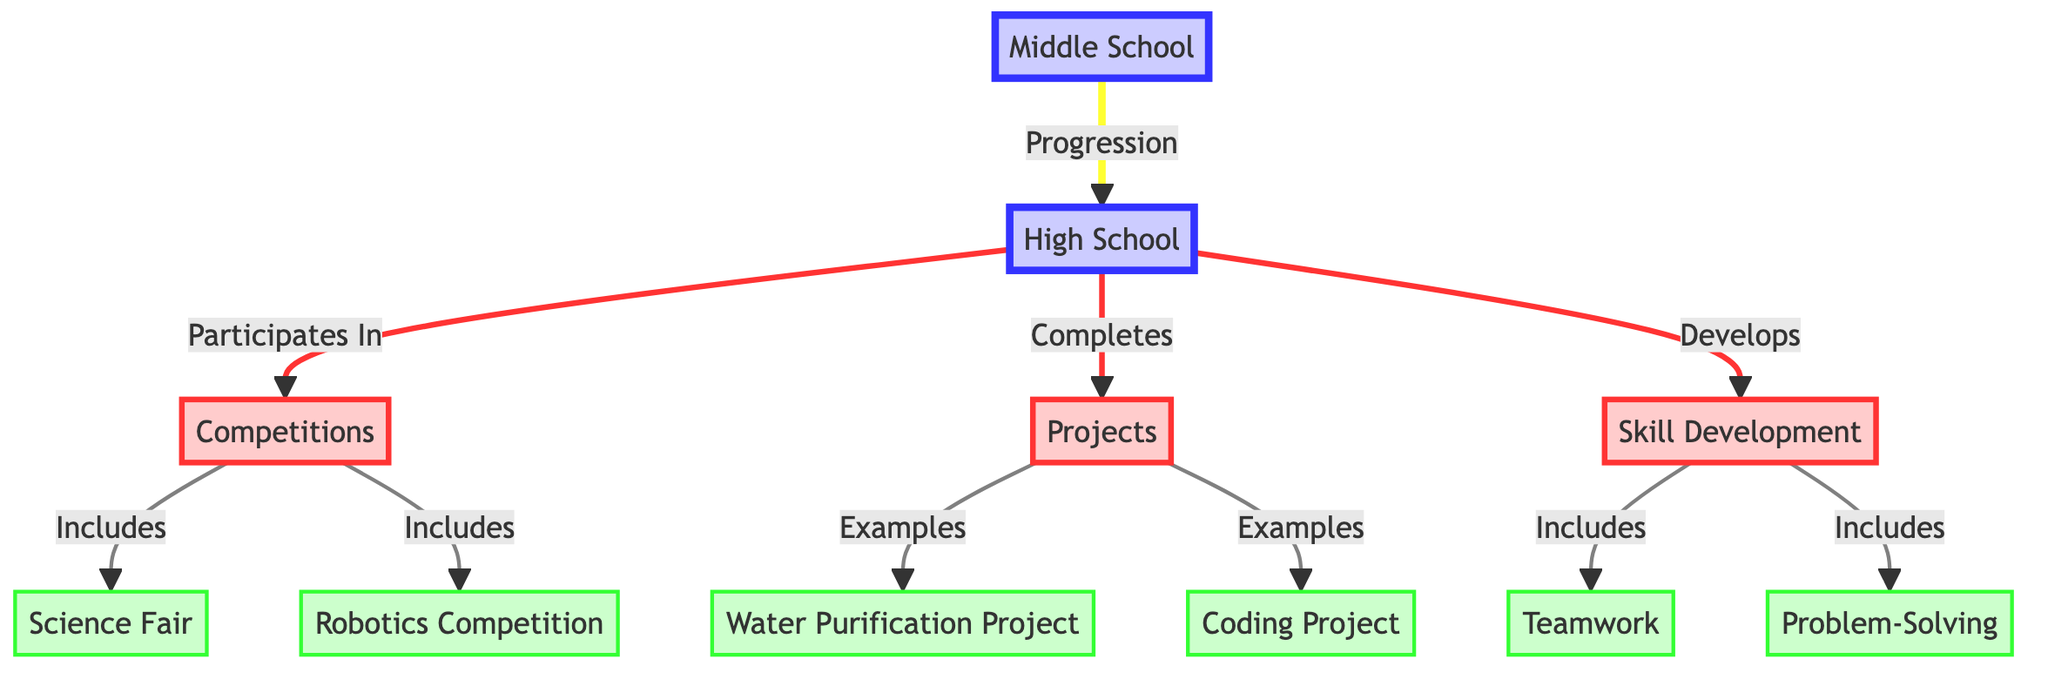What age groups are represented in the diagram? The diagram compares two age groups: Middle School and High School, as indicated by the two main nodes labeled accordingly.
Answer: Middle School, High School How many categories of achievements are shown in the diagram? The diagram has three distinct categories: Competitions, Projects, and Skill Development. This can be verified by counting the nodes connected to the age group nodes that signify these categories.
Answer: Three Which competition is included under the Competitions category? In the diagram, one of the competitions listed is the Science Fair, shown as an item node linked to the Competitions category.
Answer: Science Fair What type of project is represented in the Projects category? The Projects category includes two specific types of projects: Water Purification Project and Coding Project. Since the question asks for one, either can be chosen, but the Water Purification Project is an example listed first.
Answer: Water Purification Project What skills are emphasized under the Skill Development category? The Skill Development category includes two specific skills: Teamwork and Problem-Solving. The relationship is established through the linkage of item nodes to this category.
Answer: Teamwork What does the flow from Middle School to High School signify? The flow from Middle School to High School indicates a progression, which suggests that Middle School students advance to High School. This is represented by the directed link labeled "Progression."
Answer: Progression How does High School participation in competitions relate to skill development? The diagram establishes a direct link between High School participation in Competitions and skill development, implying that participating in competitions contributes to the development of skills.
Answer: Develops skills Which projects are listed under the Projects category? The Projects category contains two linked items: Water Purification Project and Coding Project, which can be distinguished as separate examples under this category.
Answer: Water Purification Project, Coding Project What visual distinction is made for the nodes relating to High School? The nodes connected to High School have a specific fill color and stroke style assigned to them, indicating a clear visual distinction from the other categories and age groups.
Answer: High School distinction 